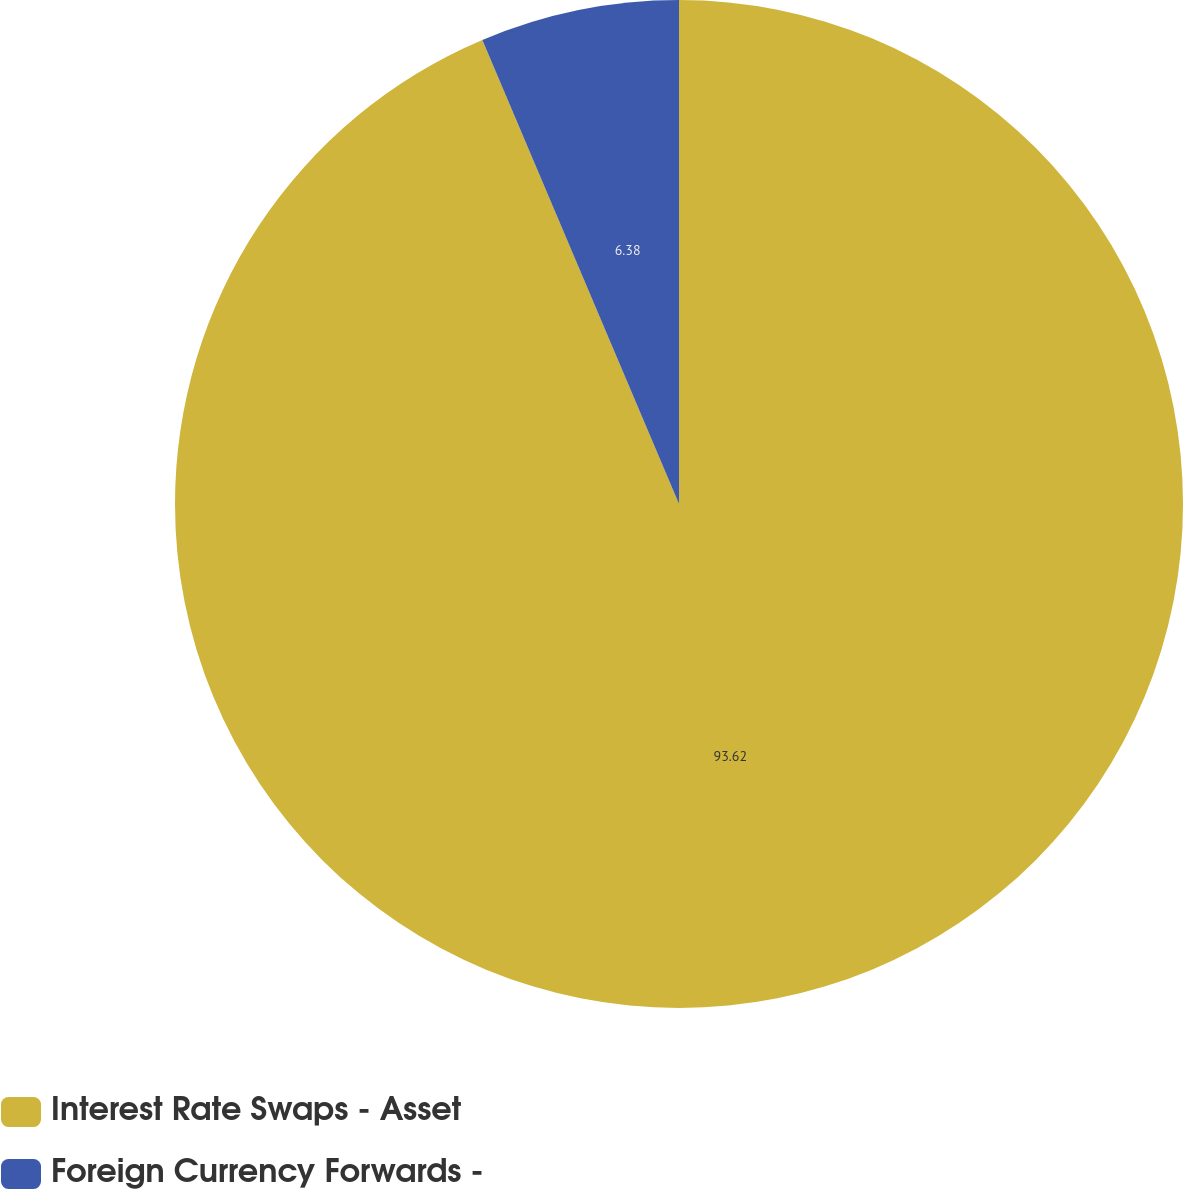Convert chart. <chart><loc_0><loc_0><loc_500><loc_500><pie_chart><fcel>Interest Rate Swaps - Asset<fcel>Foreign Currency Forwards -<nl><fcel>93.62%<fcel>6.38%<nl></chart> 